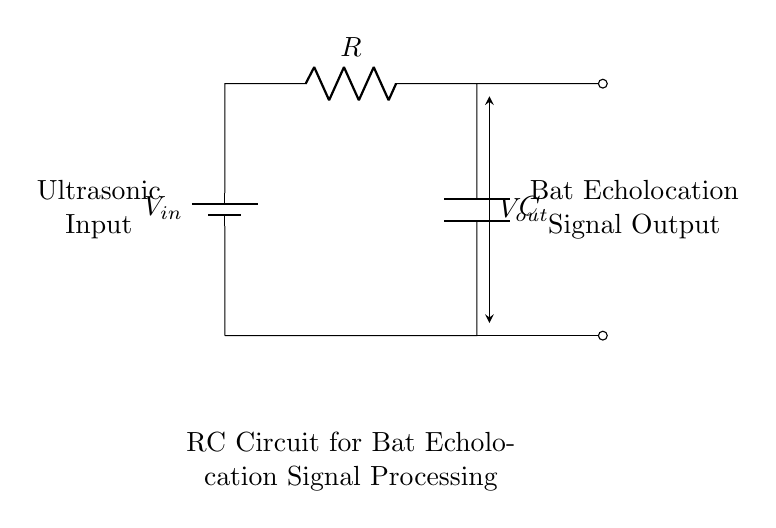What is the type of input in this RC circuit? The input is described as "Ultrasonic Input," which indicates that the circuit processes signals at ultrasonic frequencies.
Answer: Ultrasonic Input What is the functionality of the capacitor in the circuit? The capacitor in an RC circuit is used to smooth out the output signal and filter frequencies, which is vital for processing the echolocation signals effectively.
Answer: Smoothing What is the position of the voltage output in the circuit? The voltage output is connected across the capacitor and is indicated as a point where the output signal is taken for further processing; it is between the capacitor and the resistor.
Answer: Between C and R What type of circuit is represented by these components? The circuit is an RC (Resistor-Capacitor) circuit, which consists of a resistor and a capacitor connected in series, often used for filtering and timing applications.
Answer: RC circuit What is being processed in this circuit design? The circuit is designed to process "Bat Echolocation Signal Output," which implies it is tailored to analyze the signals emitted by bats.
Answer: Bat Echolocation Signal How do the resistance and capacitance values affect the time constant of this circuit? The time constant in an RC circuit is calculated as the product of resistance and capacitance (τ = R * C), which determines how quickly the circuit responds to changes in input. It affects the speed of echolocation processing.
Answer: τ = R * C What is the relationship between the input and output in this circuit? The output voltage (Vout) is influenced by the input voltage (Vin) and the time constants of the resistor and capacitor, meaning it will vary based on the input signal characteristics.
Answer: Depends on Vin and τ 